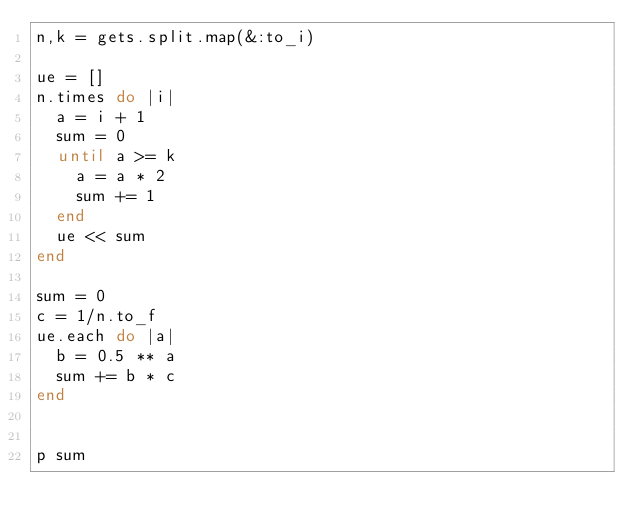Convert code to text. <code><loc_0><loc_0><loc_500><loc_500><_Ruby_>n,k = gets.split.map(&:to_i)

ue = []
n.times do |i|
  a = i + 1
  sum = 0
  until a >= k
    a = a * 2
    sum += 1
  end
  ue << sum
end

sum = 0
c = 1/n.to_f
ue.each do |a|
  b = 0.5 ** a
  sum += b * c
end


p sum</code> 